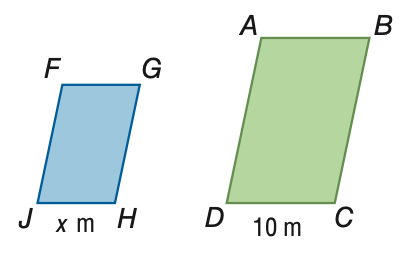Answer the mathemtical geometry problem and directly provide the correct option letter.
Question: The area of \parallelogram A B C D is 150 square meters. The area of \parallelogram F G H J is 54 square meters. If \parallelogram A B C D \sim \parallelogram F G H J, find the value of x.
Choices: A: 3.6 B: 6 C: 16.7 D: 27.8 B 